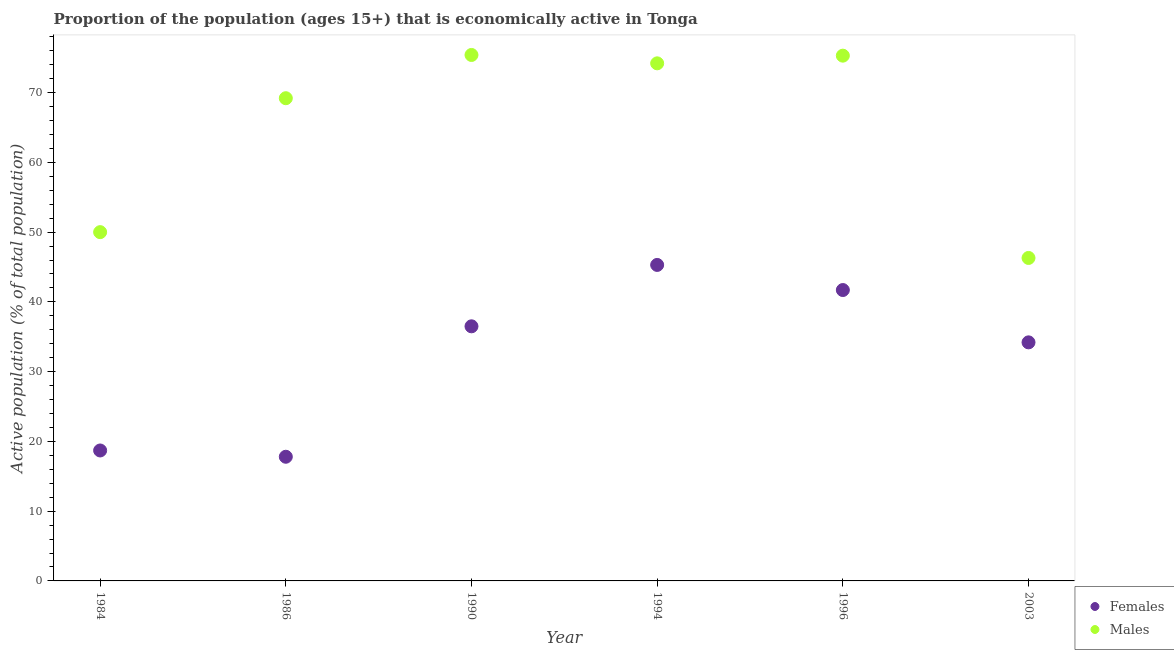How many different coloured dotlines are there?
Your answer should be very brief. 2. What is the percentage of economically active male population in 1996?
Make the answer very short. 75.3. Across all years, what is the maximum percentage of economically active male population?
Your answer should be compact. 75.4. Across all years, what is the minimum percentage of economically active male population?
Make the answer very short. 46.3. In which year was the percentage of economically active male population maximum?
Keep it short and to the point. 1990. In which year was the percentage of economically active female population minimum?
Your response must be concise. 1986. What is the total percentage of economically active female population in the graph?
Give a very brief answer. 194.2. What is the difference between the percentage of economically active female population in 1984 and that in 1994?
Your response must be concise. -26.6. What is the difference between the percentage of economically active female population in 1990 and the percentage of economically active male population in 1986?
Keep it short and to the point. -32.7. What is the average percentage of economically active male population per year?
Offer a very short reply. 65.07. In the year 1990, what is the difference between the percentage of economically active male population and percentage of economically active female population?
Keep it short and to the point. 38.9. What is the ratio of the percentage of economically active male population in 1984 to that in 1986?
Your answer should be very brief. 0.72. Is the percentage of economically active female population in 1984 less than that in 1994?
Your response must be concise. Yes. What is the difference between the highest and the second highest percentage of economically active female population?
Make the answer very short. 3.6. What is the difference between the highest and the lowest percentage of economically active male population?
Provide a succinct answer. 29.1. In how many years, is the percentage of economically active female population greater than the average percentage of economically active female population taken over all years?
Offer a terse response. 4. Is the sum of the percentage of economically active female population in 1984 and 1986 greater than the maximum percentage of economically active male population across all years?
Offer a terse response. No. Is the percentage of economically active male population strictly greater than the percentage of economically active female population over the years?
Offer a terse response. Yes. How many dotlines are there?
Offer a very short reply. 2. Are the values on the major ticks of Y-axis written in scientific E-notation?
Your answer should be compact. No. Does the graph contain grids?
Provide a short and direct response. No. How many legend labels are there?
Your response must be concise. 2. How are the legend labels stacked?
Make the answer very short. Vertical. What is the title of the graph?
Offer a terse response. Proportion of the population (ages 15+) that is economically active in Tonga. Does "Stunting" appear as one of the legend labels in the graph?
Provide a succinct answer. No. What is the label or title of the X-axis?
Make the answer very short. Year. What is the label or title of the Y-axis?
Your answer should be very brief. Active population (% of total population). What is the Active population (% of total population) of Females in 1984?
Ensure brevity in your answer.  18.7. What is the Active population (% of total population) of Females in 1986?
Your answer should be very brief. 17.8. What is the Active population (% of total population) of Males in 1986?
Keep it short and to the point. 69.2. What is the Active population (% of total population) in Females in 1990?
Make the answer very short. 36.5. What is the Active population (% of total population) of Males in 1990?
Offer a very short reply. 75.4. What is the Active population (% of total population) in Females in 1994?
Make the answer very short. 45.3. What is the Active population (% of total population) of Males in 1994?
Provide a short and direct response. 74.2. What is the Active population (% of total population) in Females in 1996?
Your answer should be compact. 41.7. What is the Active population (% of total population) in Males in 1996?
Your answer should be very brief. 75.3. What is the Active population (% of total population) of Females in 2003?
Your answer should be very brief. 34.2. What is the Active population (% of total population) of Males in 2003?
Your answer should be compact. 46.3. Across all years, what is the maximum Active population (% of total population) in Females?
Your answer should be very brief. 45.3. Across all years, what is the maximum Active population (% of total population) in Males?
Ensure brevity in your answer.  75.4. Across all years, what is the minimum Active population (% of total population) in Females?
Keep it short and to the point. 17.8. Across all years, what is the minimum Active population (% of total population) in Males?
Your answer should be very brief. 46.3. What is the total Active population (% of total population) of Females in the graph?
Keep it short and to the point. 194.2. What is the total Active population (% of total population) in Males in the graph?
Give a very brief answer. 390.4. What is the difference between the Active population (% of total population) in Females in 1984 and that in 1986?
Your response must be concise. 0.9. What is the difference between the Active population (% of total population) of Males in 1984 and that in 1986?
Your answer should be very brief. -19.2. What is the difference between the Active population (% of total population) in Females in 1984 and that in 1990?
Offer a very short reply. -17.8. What is the difference between the Active population (% of total population) in Males in 1984 and that in 1990?
Your answer should be very brief. -25.4. What is the difference between the Active population (% of total population) of Females in 1984 and that in 1994?
Provide a short and direct response. -26.6. What is the difference between the Active population (% of total population) in Males in 1984 and that in 1994?
Provide a short and direct response. -24.2. What is the difference between the Active population (% of total population) in Males in 1984 and that in 1996?
Offer a terse response. -25.3. What is the difference between the Active population (% of total population) of Females in 1984 and that in 2003?
Ensure brevity in your answer.  -15.5. What is the difference between the Active population (% of total population) of Females in 1986 and that in 1990?
Provide a succinct answer. -18.7. What is the difference between the Active population (% of total population) in Females in 1986 and that in 1994?
Give a very brief answer. -27.5. What is the difference between the Active population (% of total population) of Males in 1986 and that in 1994?
Give a very brief answer. -5. What is the difference between the Active population (% of total population) in Females in 1986 and that in 1996?
Offer a terse response. -23.9. What is the difference between the Active population (% of total population) in Females in 1986 and that in 2003?
Your response must be concise. -16.4. What is the difference between the Active population (% of total population) of Males in 1986 and that in 2003?
Provide a short and direct response. 22.9. What is the difference between the Active population (% of total population) in Males in 1990 and that in 1996?
Your answer should be very brief. 0.1. What is the difference between the Active population (% of total population) in Males in 1990 and that in 2003?
Provide a short and direct response. 29.1. What is the difference between the Active population (% of total population) in Females in 1994 and that in 1996?
Provide a short and direct response. 3.6. What is the difference between the Active population (% of total population) of Females in 1994 and that in 2003?
Your response must be concise. 11.1. What is the difference between the Active population (% of total population) in Males in 1994 and that in 2003?
Give a very brief answer. 27.9. What is the difference between the Active population (% of total population) of Females in 1996 and that in 2003?
Offer a terse response. 7.5. What is the difference between the Active population (% of total population) of Males in 1996 and that in 2003?
Your response must be concise. 29. What is the difference between the Active population (% of total population) in Females in 1984 and the Active population (% of total population) in Males in 1986?
Your answer should be compact. -50.5. What is the difference between the Active population (% of total population) in Females in 1984 and the Active population (% of total population) in Males in 1990?
Ensure brevity in your answer.  -56.7. What is the difference between the Active population (% of total population) of Females in 1984 and the Active population (% of total population) of Males in 1994?
Give a very brief answer. -55.5. What is the difference between the Active population (% of total population) of Females in 1984 and the Active population (% of total population) of Males in 1996?
Your answer should be very brief. -56.6. What is the difference between the Active population (% of total population) in Females in 1984 and the Active population (% of total population) in Males in 2003?
Offer a very short reply. -27.6. What is the difference between the Active population (% of total population) of Females in 1986 and the Active population (% of total population) of Males in 1990?
Give a very brief answer. -57.6. What is the difference between the Active population (% of total population) in Females in 1986 and the Active population (% of total population) in Males in 1994?
Provide a short and direct response. -56.4. What is the difference between the Active population (% of total population) in Females in 1986 and the Active population (% of total population) in Males in 1996?
Offer a very short reply. -57.5. What is the difference between the Active population (% of total population) of Females in 1986 and the Active population (% of total population) of Males in 2003?
Provide a succinct answer. -28.5. What is the difference between the Active population (% of total population) in Females in 1990 and the Active population (% of total population) in Males in 1994?
Your response must be concise. -37.7. What is the difference between the Active population (% of total population) of Females in 1990 and the Active population (% of total population) of Males in 1996?
Ensure brevity in your answer.  -38.8. What is the difference between the Active population (% of total population) of Females in 1996 and the Active population (% of total population) of Males in 2003?
Your response must be concise. -4.6. What is the average Active population (% of total population) of Females per year?
Provide a short and direct response. 32.37. What is the average Active population (% of total population) of Males per year?
Offer a very short reply. 65.07. In the year 1984, what is the difference between the Active population (% of total population) in Females and Active population (% of total population) in Males?
Provide a succinct answer. -31.3. In the year 1986, what is the difference between the Active population (% of total population) of Females and Active population (% of total population) of Males?
Provide a short and direct response. -51.4. In the year 1990, what is the difference between the Active population (% of total population) of Females and Active population (% of total population) of Males?
Make the answer very short. -38.9. In the year 1994, what is the difference between the Active population (% of total population) in Females and Active population (% of total population) in Males?
Provide a short and direct response. -28.9. In the year 1996, what is the difference between the Active population (% of total population) in Females and Active population (% of total population) in Males?
Your answer should be very brief. -33.6. In the year 2003, what is the difference between the Active population (% of total population) in Females and Active population (% of total population) in Males?
Your response must be concise. -12.1. What is the ratio of the Active population (% of total population) in Females in 1984 to that in 1986?
Give a very brief answer. 1.05. What is the ratio of the Active population (% of total population) in Males in 1984 to that in 1986?
Offer a very short reply. 0.72. What is the ratio of the Active population (% of total population) in Females in 1984 to that in 1990?
Make the answer very short. 0.51. What is the ratio of the Active population (% of total population) in Males in 1984 to that in 1990?
Offer a terse response. 0.66. What is the ratio of the Active population (% of total population) of Females in 1984 to that in 1994?
Give a very brief answer. 0.41. What is the ratio of the Active population (% of total population) of Males in 1984 to that in 1994?
Your answer should be compact. 0.67. What is the ratio of the Active population (% of total population) in Females in 1984 to that in 1996?
Your answer should be compact. 0.45. What is the ratio of the Active population (% of total population) of Males in 1984 to that in 1996?
Provide a succinct answer. 0.66. What is the ratio of the Active population (% of total population) of Females in 1984 to that in 2003?
Provide a short and direct response. 0.55. What is the ratio of the Active population (% of total population) of Males in 1984 to that in 2003?
Keep it short and to the point. 1.08. What is the ratio of the Active population (% of total population) of Females in 1986 to that in 1990?
Give a very brief answer. 0.49. What is the ratio of the Active population (% of total population) of Males in 1986 to that in 1990?
Give a very brief answer. 0.92. What is the ratio of the Active population (% of total population) in Females in 1986 to that in 1994?
Provide a short and direct response. 0.39. What is the ratio of the Active population (% of total population) in Males in 1986 to that in 1994?
Give a very brief answer. 0.93. What is the ratio of the Active population (% of total population) in Females in 1986 to that in 1996?
Your answer should be very brief. 0.43. What is the ratio of the Active population (% of total population) in Males in 1986 to that in 1996?
Provide a succinct answer. 0.92. What is the ratio of the Active population (% of total population) of Females in 1986 to that in 2003?
Offer a terse response. 0.52. What is the ratio of the Active population (% of total population) of Males in 1986 to that in 2003?
Make the answer very short. 1.49. What is the ratio of the Active population (% of total population) of Females in 1990 to that in 1994?
Ensure brevity in your answer.  0.81. What is the ratio of the Active population (% of total population) in Males in 1990 to that in 1994?
Offer a terse response. 1.02. What is the ratio of the Active population (% of total population) in Females in 1990 to that in 1996?
Make the answer very short. 0.88. What is the ratio of the Active population (% of total population) in Males in 1990 to that in 1996?
Keep it short and to the point. 1. What is the ratio of the Active population (% of total population) in Females in 1990 to that in 2003?
Provide a succinct answer. 1.07. What is the ratio of the Active population (% of total population) in Males in 1990 to that in 2003?
Your answer should be compact. 1.63. What is the ratio of the Active population (% of total population) of Females in 1994 to that in 1996?
Offer a terse response. 1.09. What is the ratio of the Active population (% of total population) of Males in 1994 to that in 1996?
Offer a very short reply. 0.99. What is the ratio of the Active population (% of total population) of Females in 1994 to that in 2003?
Your answer should be very brief. 1.32. What is the ratio of the Active population (% of total population) of Males in 1994 to that in 2003?
Keep it short and to the point. 1.6. What is the ratio of the Active population (% of total population) in Females in 1996 to that in 2003?
Keep it short and to the point. 1.22. What is the ratio of the Active population (% of total population) of Males in 1996 to that in 2003?
Your response must be concise. 1.63. What is the difference between the highest and the second highest Active population (% of total population) of Females?
Provide a succinct answer. 3.6. What is the difference between the highest and the second highest Active population (% of total population) in Males?
Your answer should be compact. 0.1. What is the difference between the highest and the lowest Active population (% of total population) in Females?
Offer a terse response. 27.5. What is the difference between the highest and the lowest Active population (% of total population) in Males?
Your answer should be very brief. 29.1. 